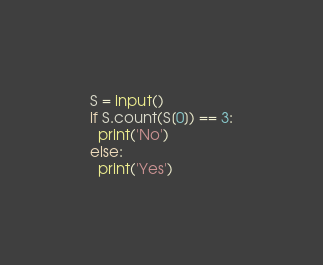<code> <loc_0><loc_0><loc_500><loc_500><_Python_>S = input()
if S.count(S[0]) == 3:
  print('No')
else:
  print('Yes')</code> 